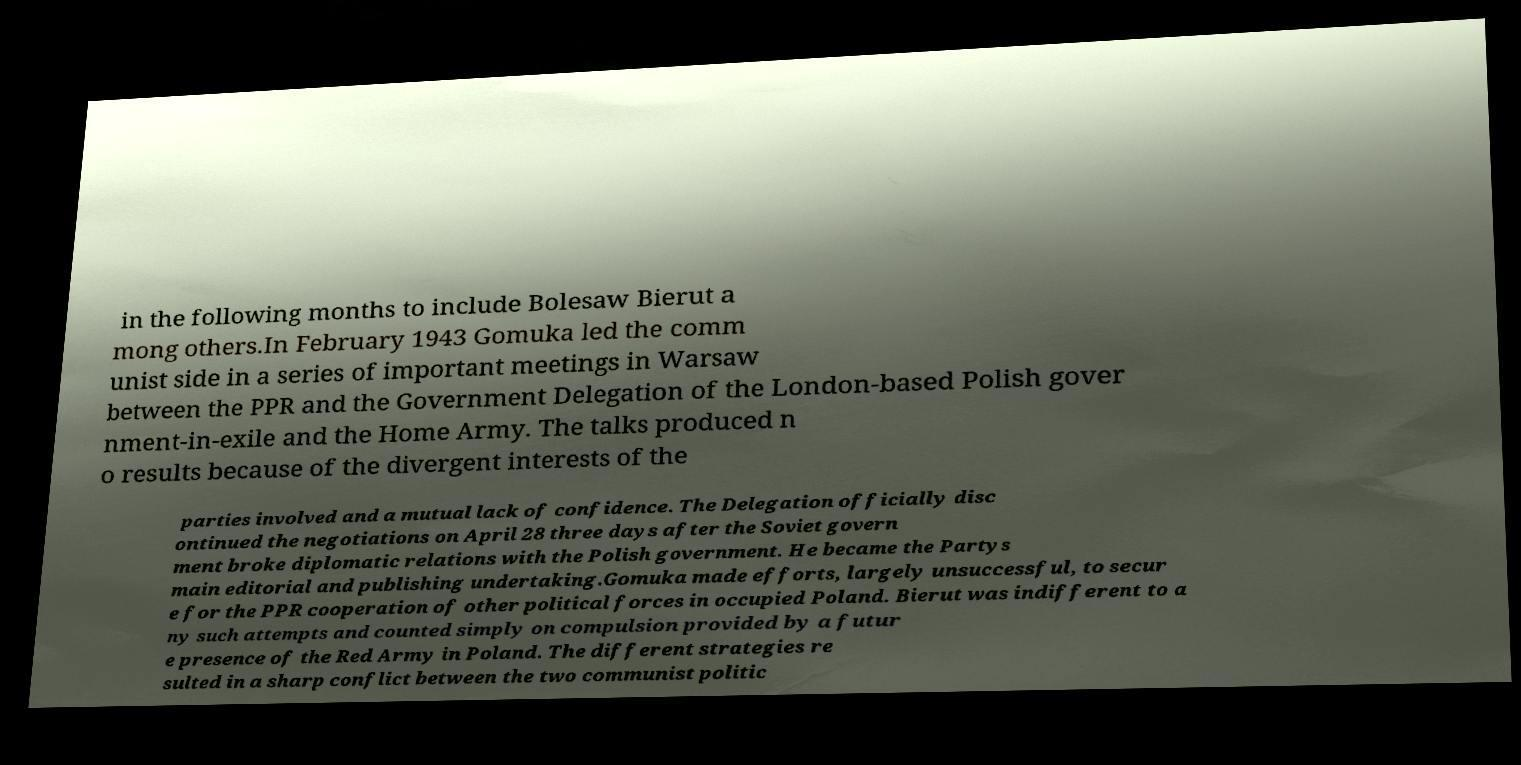For documentation purposes, I need the text within this image transcribed. Could you provide that? in the following months to include Bolesaw Bierut a mong others.In February 1943 Gomuka led the comm unist side in a series of important meetings in Warsaw between the PPR and the Government Delegation of the London-based Polish gover nment-in-exile and the Home Army. The talks produced n o results because of the divergent interests of the parties involved and a mutual lack of confidence. The Delegation officially disc ontinued the negotiations on April 28 three days after the Soviet govern ment broke diplomatic relations with the Polish government. He became the Partys main editorial and publishing undertaking.Gomuka made efforts, largely unsuccessful, to secur e for the PPR cooperation of other political forces in occupied Poland. Bierut was indifferent to a ny such attempts and counted simply on compulsion provided by a futur e presence of the Red Army in Poland. The different strategies re sulted in a sharp conflict between the two communist politic 